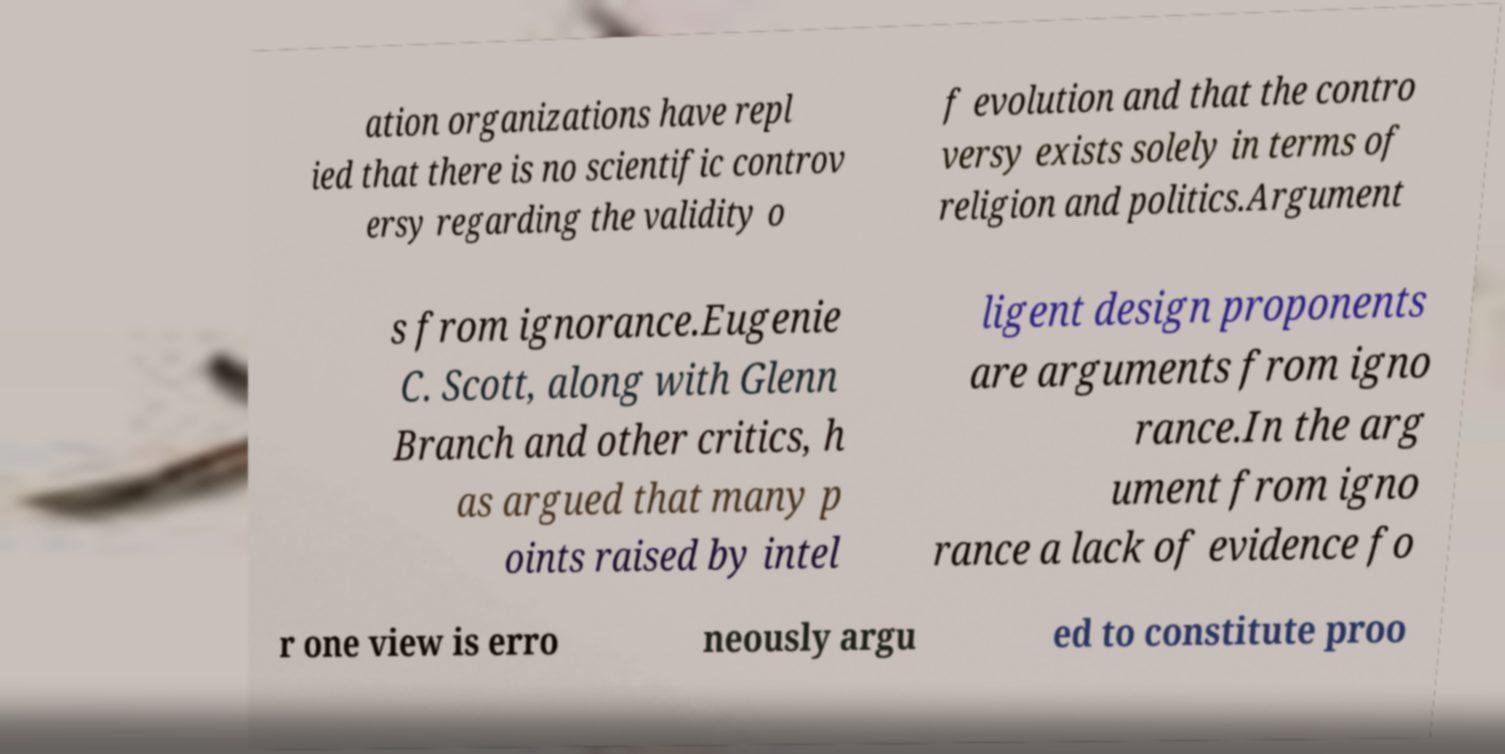There's text embedded in this image that I need extracted. Can you transcribe it verbatim? ation organizations have repl ied that there is no scientific controv ersy regarding the validity o f evolution and that the contro versy exists solely in terms of religion and politics.Argument s from ignorance.Eugenie C. Scott, along with Glenn Branch and other critics, h as argued that many p oints raised by intel ligent design proponents are arguments from igno rance.In the arg ument from igno rance a lack of evidence fo r one view is erro neously argu ed to constitute proo 